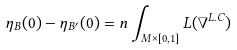Convert formula to latex. <formula><loc_0><loc_0><loc_500><loc_500>\eta _ { B } ( 0 ) - \eta _ { B ^ { \prime } } ( 0 ) = n \int _ { M \times [ 0 , 1 ] } L ( \nabla ^ { L . C } )</formula> 